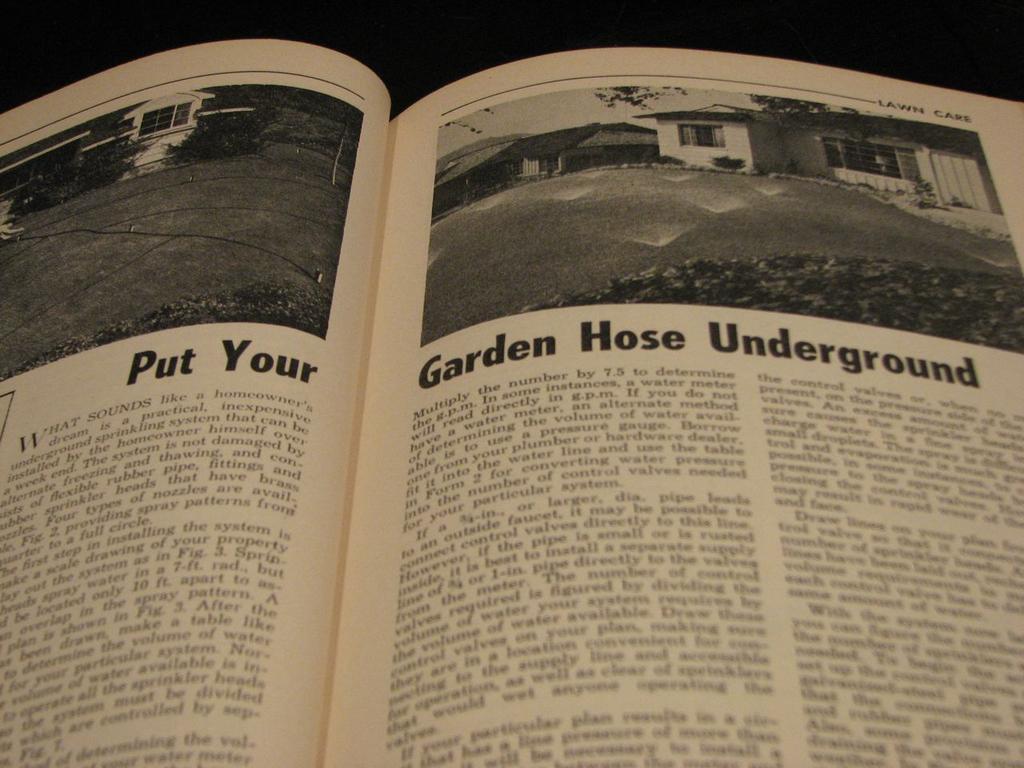What is the first word written on the right page?
Provide a succinct answer. Garden. 